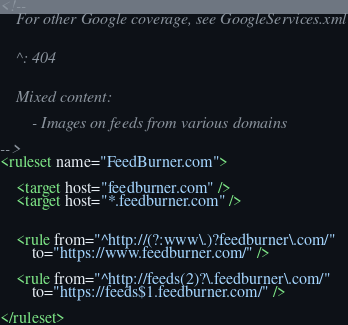Convert code to text. <code><loc_0><loc_0><loc_500><loc_500><_XML_><!--
	For other Google coverage, see GoogleServices.xml


	^: 404


	Mixed content:

		- Images on feeds from various domains

-->
<ruleset name="FeedBurner.com">

	<target host="feedburner.com" />
	<target host="*.feedburner.com" />


	<rule from="^http://(?:www\.)?feedburner\.com/"
		to="https://www.feedburner.com/" />

	<rule from="^http://feeds(2)?\.feedburner\.com/"
		to="https://feeds$1.feedburner.com/" />

</ruleset>
</code> 